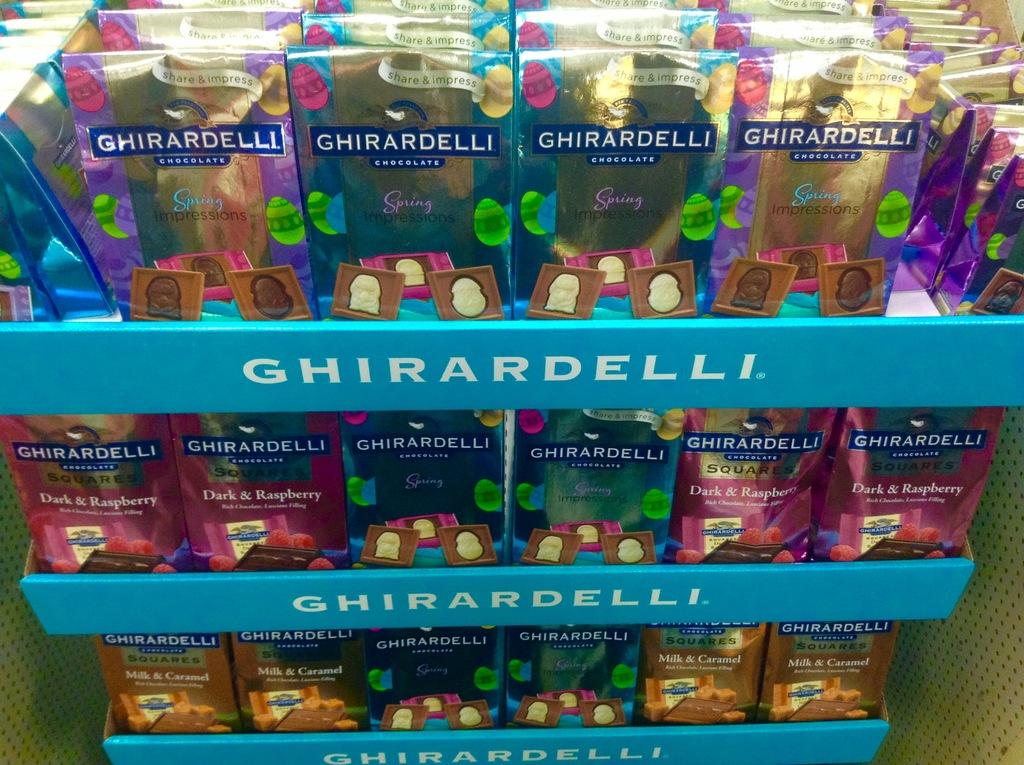Provide a one-sentence caption for the provided image. A display stand for Ghirardelli boxes of a variety of colors. 